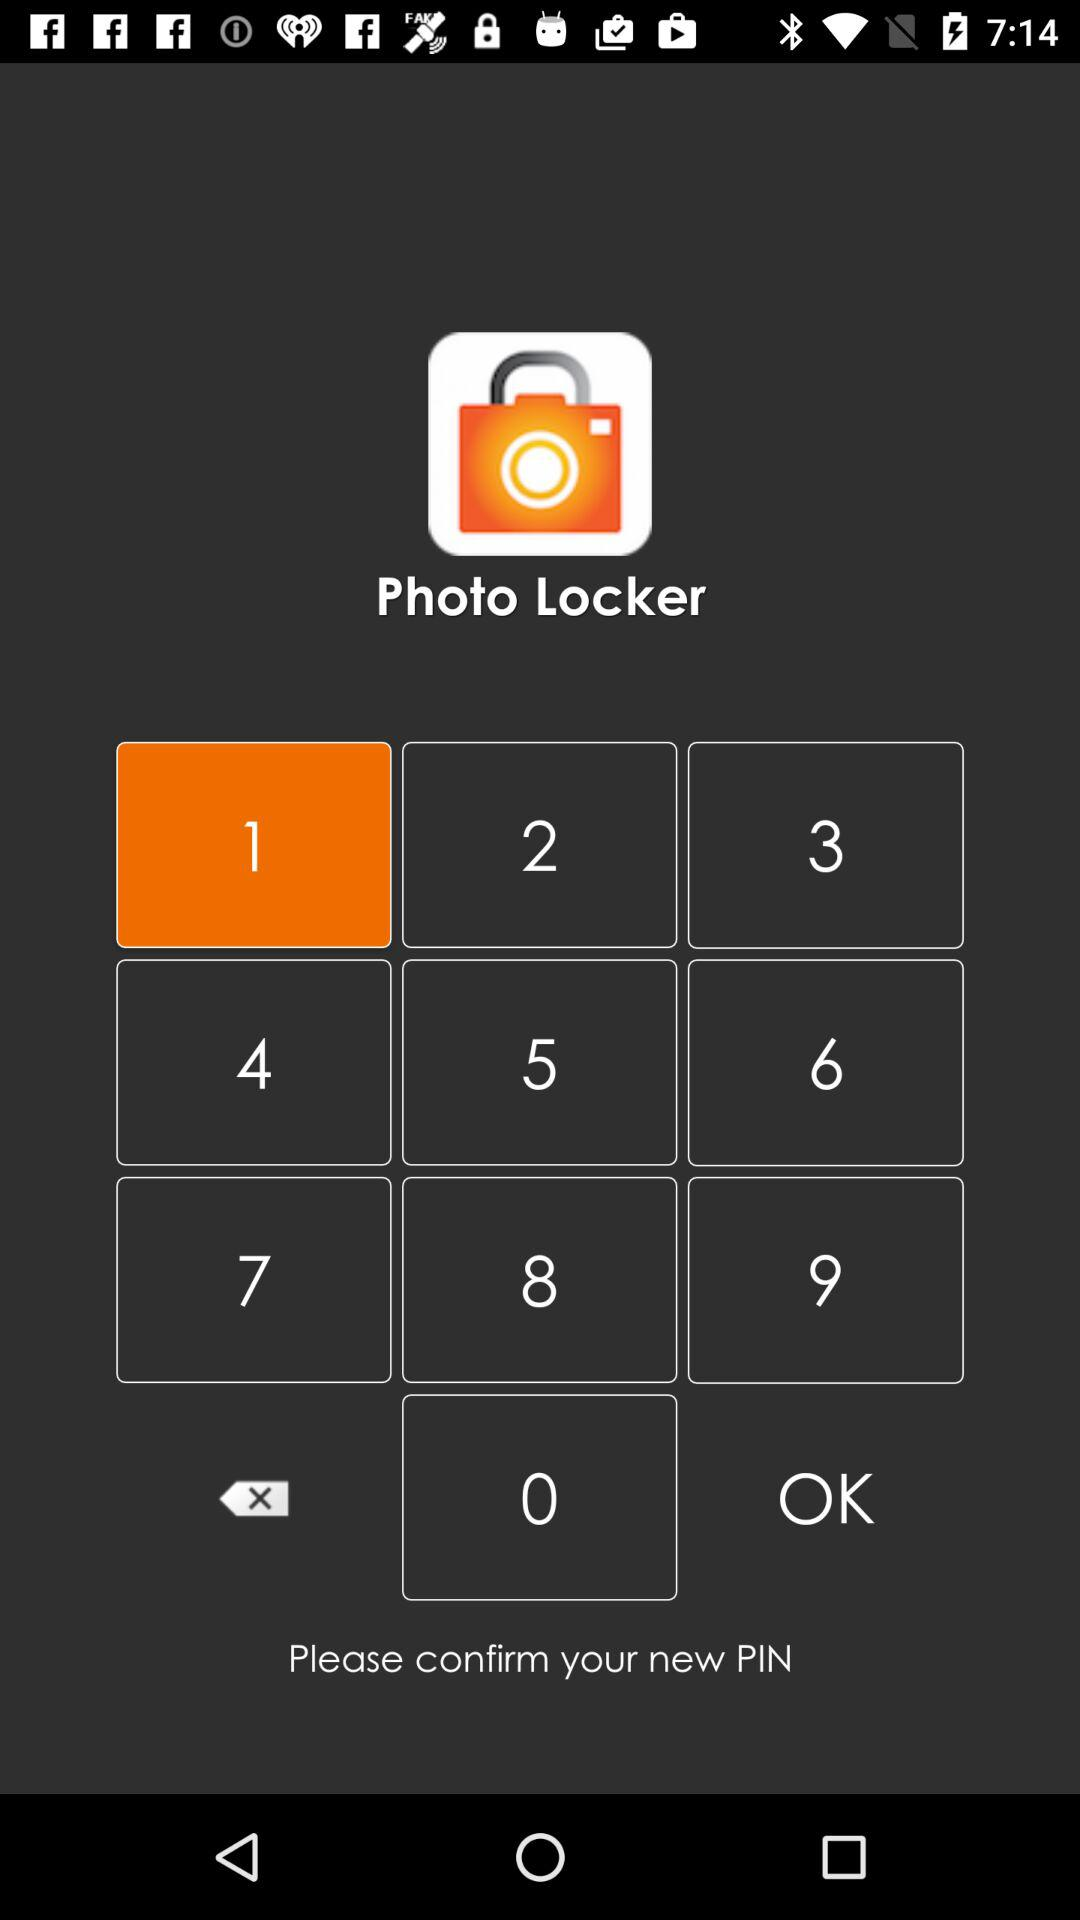Which number is highlighted? The highlighted number is 1. 